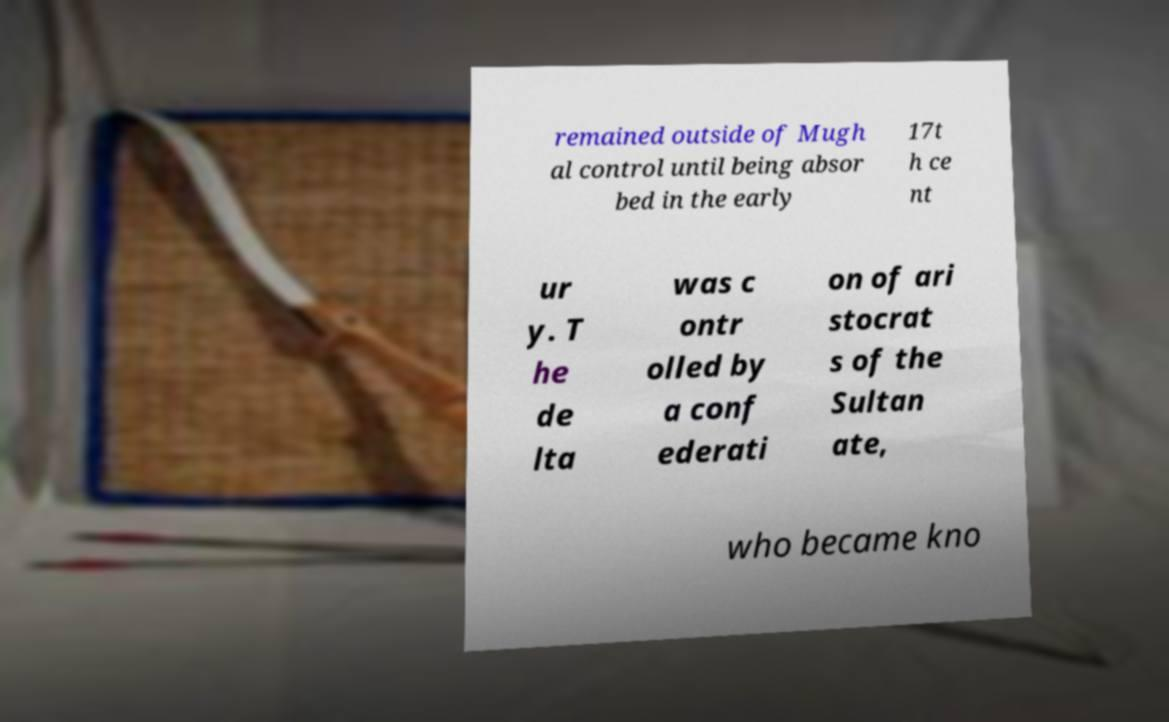What messages or text are displayed in this image? I need them in a readable, typed format. remained outside of Mugh al control until being absor bed in the early 17t h ce nt ur y. T he de lta was c ontr olled by a conf ederati on of ari stocrat s of the Sultan ate, who became kno 